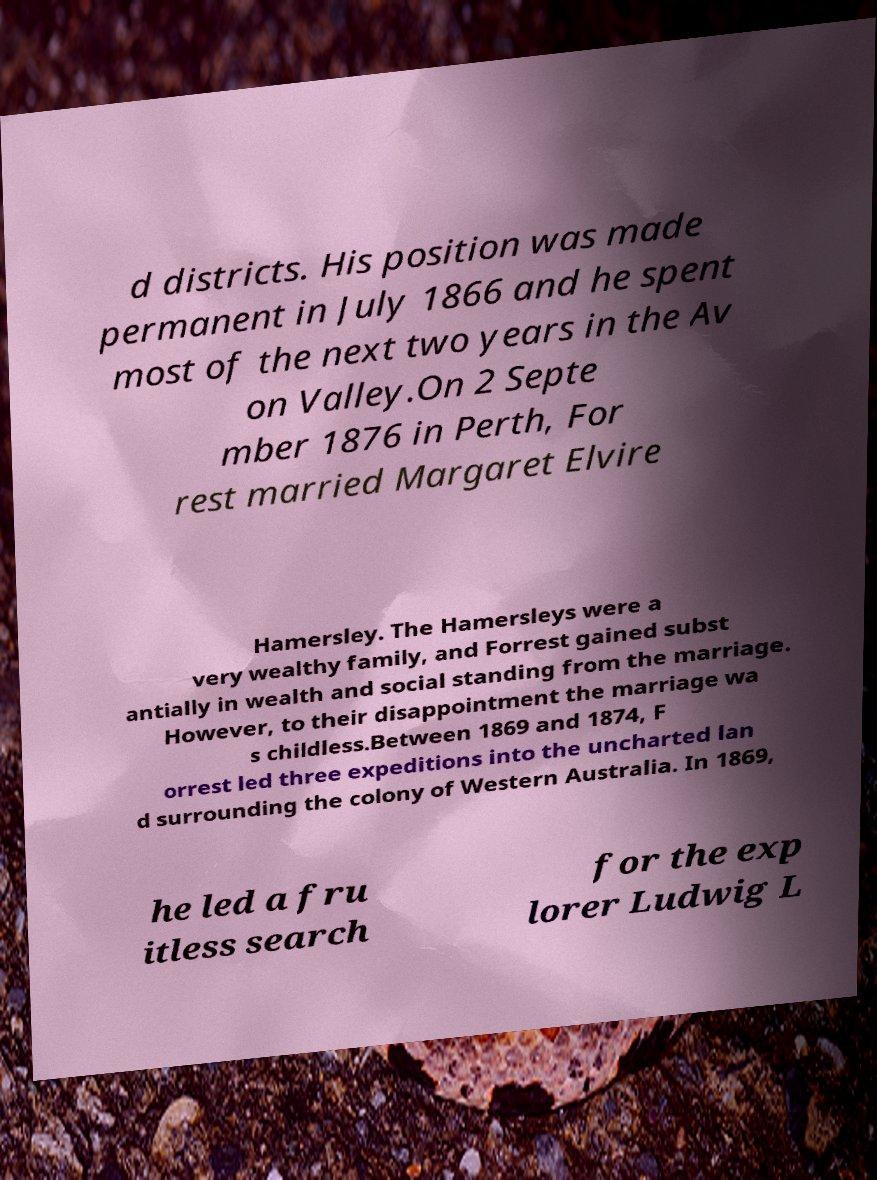What messages or text are displayed in this image? I need them in a readable, typed format. d districts. His position was made permanent in July 1866 and he spent most of the next two years in the Av on Valley.On 2 Septe mber 1876 in Perth, For rest married Margaret Elvire Hamersley. The Hamersleys were a very wealthy family, and Forrest gained subst antially in wealth and social standing from the marriage. However, to their disappointment the marriage wa s childless.Between 1869 and 1874, F orrest led three expeditions into the uncharted lan d surrounding the colony of Western Australia. In 1869, he led a fru itless search for the exp lorer Ludwig L 